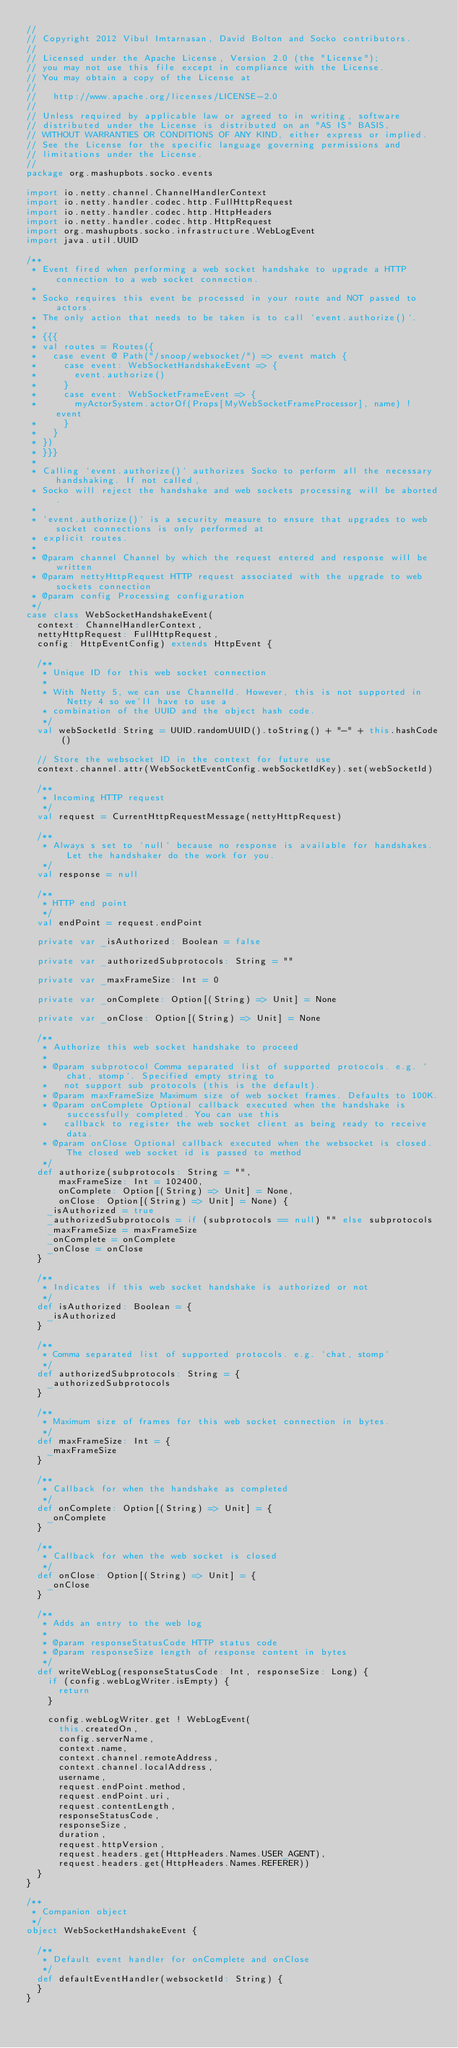<code> <loc_0><loc_0><loc_500><loc_500><_Scala_>//
// Copyright 2012 Vibul Imtarnasan, David Bolton and Socko contributors.
//
// Licensed under the Apache License, Version 2.0 (the "License");
// you may not use this file except in compliance with the License.
// You may obtain a copy of the License at
//
//   http://www.apache.org/licenses/LICENSE-2.0
//
// Unless required by applicable law or agreed to in writing, software
// distributed under the License is distributed on an "AS IS" BASIS,
// WITHOUT WARRANTIES OR CONDITIONS OF ANY KIND, either express or implied.
// See the License for the specific language governing permissions and
// limitations under the License.
//
package org.mashupbots.socko.events

import io.netty.channel.ChannelHandlerContext
import io.netty.handler.codec.http.FullHttpRequest
import io.netty.handler.codec.http.HttpHeaders
import io.netty.handler.codec.http.HttpRequest
import org.mashupbots.socko.infrastructure.WebLogEvent
import java.util.UUID

/**
 * Event fired when performing a web socket handshake to upgrade a HTTP connection to a web socket connection.
 *
 * Socko requires this event be processed in your route and NOT passed to actors.
 * The only action that needs to be taken is to call `event.authorize()`.
 *
 * {{{
 * val routes = Routes({
 *   case event @ Path("/snoop/websocket/") => event match {
 *     case event: WebSocketHandshakeEvent => {
 *       event.authorize()
 *     }
 *     case event: WebSocketFrameEvent => {
 *       myActorSystem.actorOf(Props[MyWebSocketFrameProcessor], name) ! event
 *     }
 *   }
 * })
 * }}}
 *
 * Calling `event.authorize()` authorizes Socko to perform all the necessary handshaking. If not called,
 * Socko will reject the handshake and web sockets processing will be aborted.
 *
 * `event.authorize()` is a security measure to ensure that upgrades to web socket connections is only performed at
 * explicit routes.
 *
 * @param channel Channel by which the request entered and response will be written
 * @param nettyHttpRequest HTTP request associated with the upgrade to web sockets connection
 * @param config Processing configuration
 */
case class WebSocketHandshakeEvent(
  context: ChannelHandlerContext,
  nettyHttpRequest: FullHttpRequest,
  config: HttpEventConfig) extends HttpEvent {

  /**
   * Unique ID for this web socket connection
   * 
   * With Netty 5, we can use ChannelId. However, this is not supported in Netty 4 so we'll have to use a 
   * combination of the UUID and the object hash code.
   */
  val webSocketId:String = UUID.randomUUID().toString() + "-" + this.hashCode()
  
  // Store the websocket ID in the context for future use
  context.channel.attr(WebSocketEventConfig.webSocketIdKey).set(webSocketId)
  
  /**
   * Incoming HTTP request
   */
  val request = CurrentHttpRequestMessage(nettyHttpRequest)

  /**
   * Always s set to `null` because no response is available for handshakes. Let the handshaker do the work for you.
   */
  val response = null

  /**
   * HTTP end point
   */
  val endPoint = request.endPoint

  private var _isAuthorized: Boolean = false

  private var _authorizedSubprotocols: String = ""

  private var _maxFrameSize: Int = 0

  private var _onComplete: Option[(String) => Unit] = None

  private var _onClose: Option[(String) => Unit] = None
  
  /**
   * Authorize this web socket handshake to proceed
   *
   * @param subprotocol Comma separated list of supported protocols. e.g. `chat, stomp`. Specified empty string to
   *   not support sub protocols (this is the default).
   * @param maxFrameSize Maximum size of web socket frames. Defaults to 100K.
   * @param onComplete Optional callback executed when the handshake is successfully completed. You can use this 
   *   callback to register the web socket client as being ready to receive data. 
   * @param onClose Optional callback executed when the websocket is closed. The closed web socket id is passed to method
   */
  def authorize(subprotocols: String = "", 
      maxFrameSize: Int = 102400,
      onComplete: Option[(String) => Unit] = None, 
      onClose: Option[(String) => Unit] = None) {
    _isAuthorized = true
    _authorizedSubprotocols = if (subprotocols == null) "" else subprotocols
    _maxFrameSize = maxFrameSize
    _onComplete = onComplete
    _onClose = onClose
  }

  /**
   * Indicates if this web socket handshake is authorized or not
   */
  def isAuthorized: Boolean = {
    _isAuthorized
  }

  /**
   * Comma separated list of supported protocols. e.g. `chat, stomp`
   */
  def authorizedSubprotocols: String = {
    _authorizedSubprotocols
  }

  /**
   * Maximum size of frames for this web socket connection in bytes.
   */
  def maxFrameSize: Int = {
    _maxFrameSize
  }
  
  /**
   * Callback for when the handshake as completed
   */
  def onComplete: Option[(String) => Unit] = {
    _onComplete
  }

  /**
   * Callback for when the web socket is closed
   */
  def onClose: Option[(String) => Unit] = {
    _onClose
  }
  
  /**
   * Adds an entry to the web log
   *
   * @param responseStatusCode HTTP status code
   * @param responseSize length of response content in bytes
   */
  def writeWebLog(responseStatusCode: Int, responseSize: Long) {
    if (config.webLogWriter.isEmpty) {
      return
    }

    config.webLogWriter.get ! WebLogEvent(
      this.createdOn,
      config.serverName,
      context.name,
      context.channel.remoteAddress,
      context.channel.localAddress,
      username,
      request.endPoint.method,
      request.endPoint.uri,
      request.contentLength,
      responseStatusCode,
      responseSize,
      duration,
      request.httpVersion,
      request.headers.get(HttpHeaders.Names.USER_AGENT),
      request.headers.get(HttpHeaders.Names.REFERER))
  }
}

/**
 * Companion object
 */
object WebSocketHandshakeEvent {
  
  /**
   * Default event handler for onComplete and onClose
   */
  def defaultEventHandler(websocketId: String) {    
  }
}</code> 